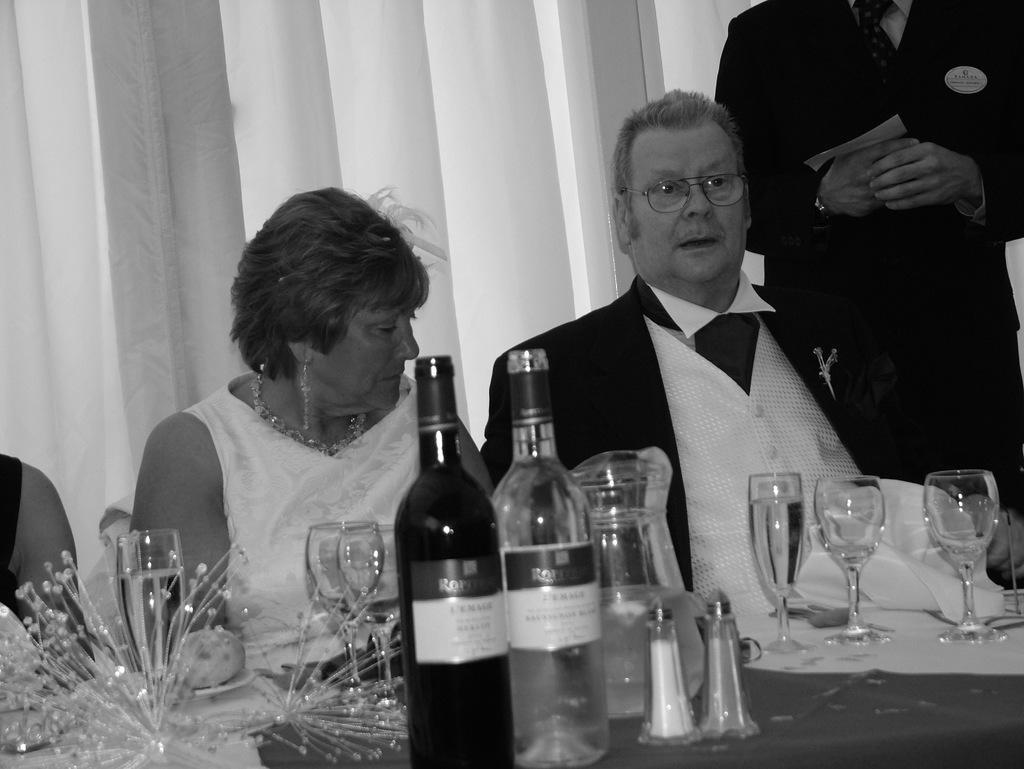Could you give a brief overview of what you see in this image? A black and white picture. These persons are sitting on a chair. In-front of them there is a table, on a table there is a jar, glasses and bottles. Beside this man a other person is standing and holding a paper. 